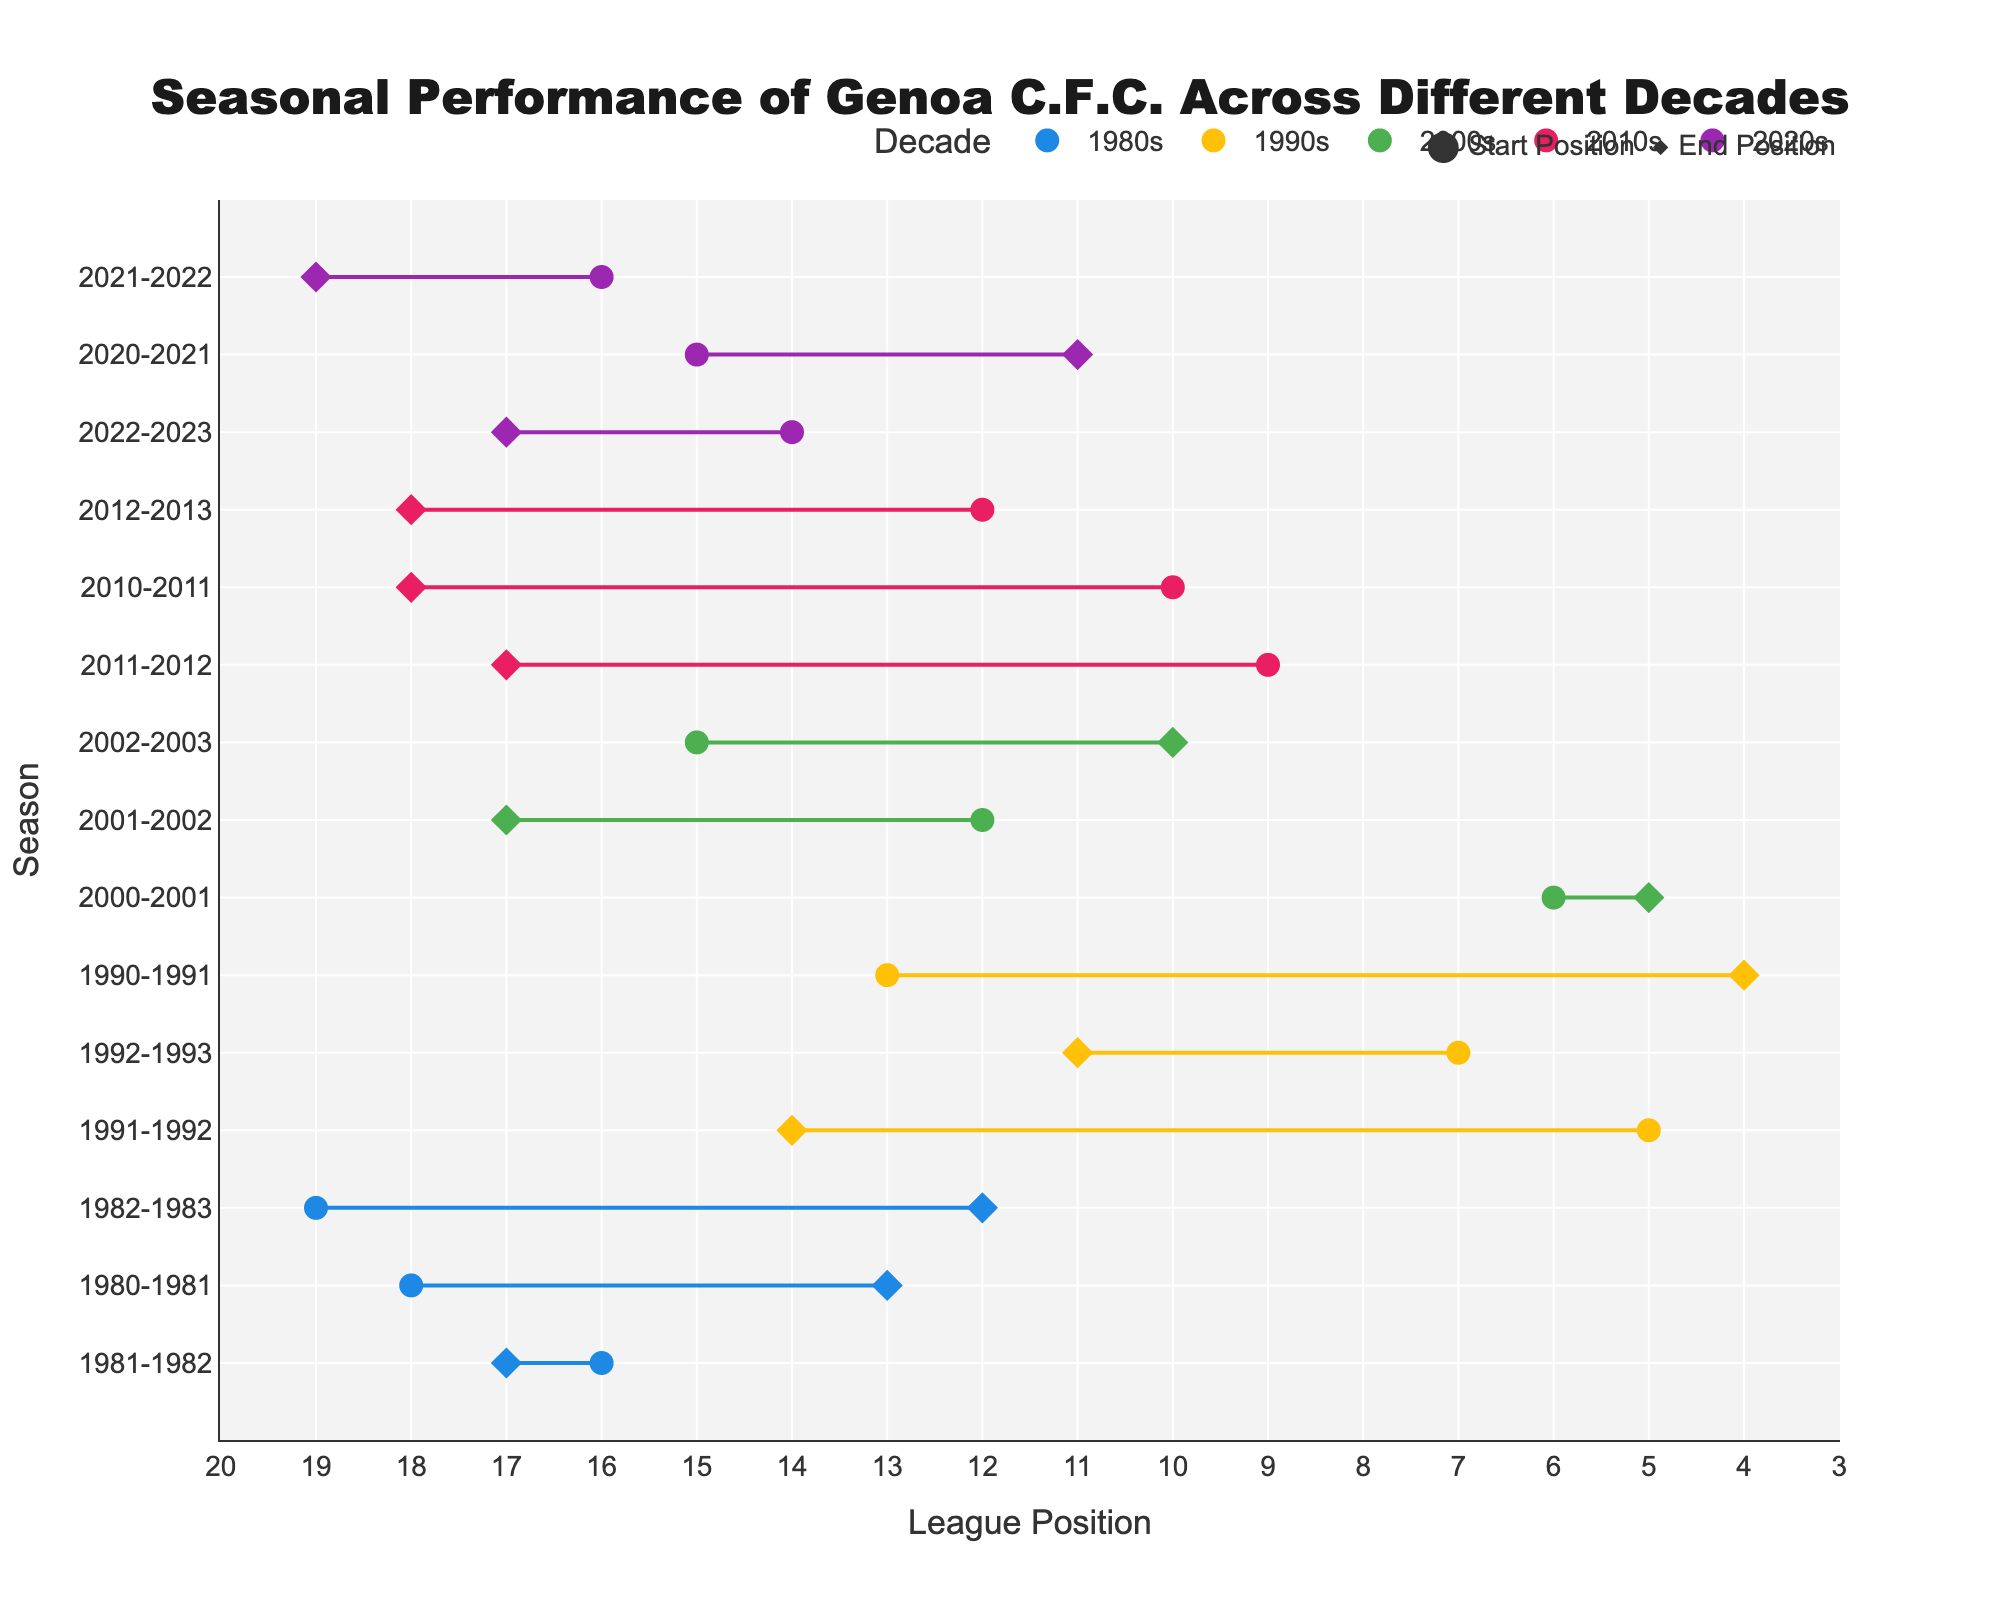What is the title of the plot? The title of the plot is located above the figure, centered both horizontally and vertically, and it states the purpose of the figure.
Answer: "Seasonal Performance of Genoa C.F.C. Across Different Decades" What is depicted on the x-axis of the plot? The x-axis represents the league positions, as shown by its title "League Position" and the range which goes from close to 0 to 20.
Answer: League Position Which decade is represented by the color '#E91E63'? The plot legend assigns colors to each decade, and the color '#E91E63' corresponds to the 2010s.
Answer: 2010s During which season did Genoa C.F.C. have the largest improvement in their league position within a single decade? Analyzing the dumbbell plot, the season with the largest improvement is visible by the longest horizontal line from left to right within a single decade. During the season 1982-1983, Genoa improved from 19th to 12th position.
Answer: 1982-1983 Which decade shows the least fluctuation in Genoa’s league position? To determine the decade with the least fluctuation, observe the length of lines for each decade. The decade with the shortest lines overall represents the least fluctuation. The 2000s show minimal change, where the start and end positions are mostly close.
Answer: 2000s What was the starting league position of Genoa in the 2020-2021 season? The position is indicated by the marker on the left end of the dumbbell for that season in the 2020s. For the 2020-2021 season, Genoa started in the 15th position.
Answer: 15th During which season in the 1990s did Genoa C.F.C. have the best ending league position? By identifying the smallest value on the x-axis for the end positions within the 1990s and corresponding to the respective season, Genoa ended in 4th position during the 1990-1991 season.
Answer: 1990-1991 How many total seasons are represented within the 2010s? Count the number of lines corresponding to the decade 2010s, as seen on the y-axis labels and colored markers within the plot. There are three seasons represented: 2010-2011, 2011-2012, and 2012-2013.
Answer: 3 In which season did Genoa end in the same position as they started within the 2000s? Identify the season where the markers are overlapping for the same position in the decade 2000s. In the 2000-2001 season, Genoa started and ended in the 5th position.
Answer: 2000-2001 